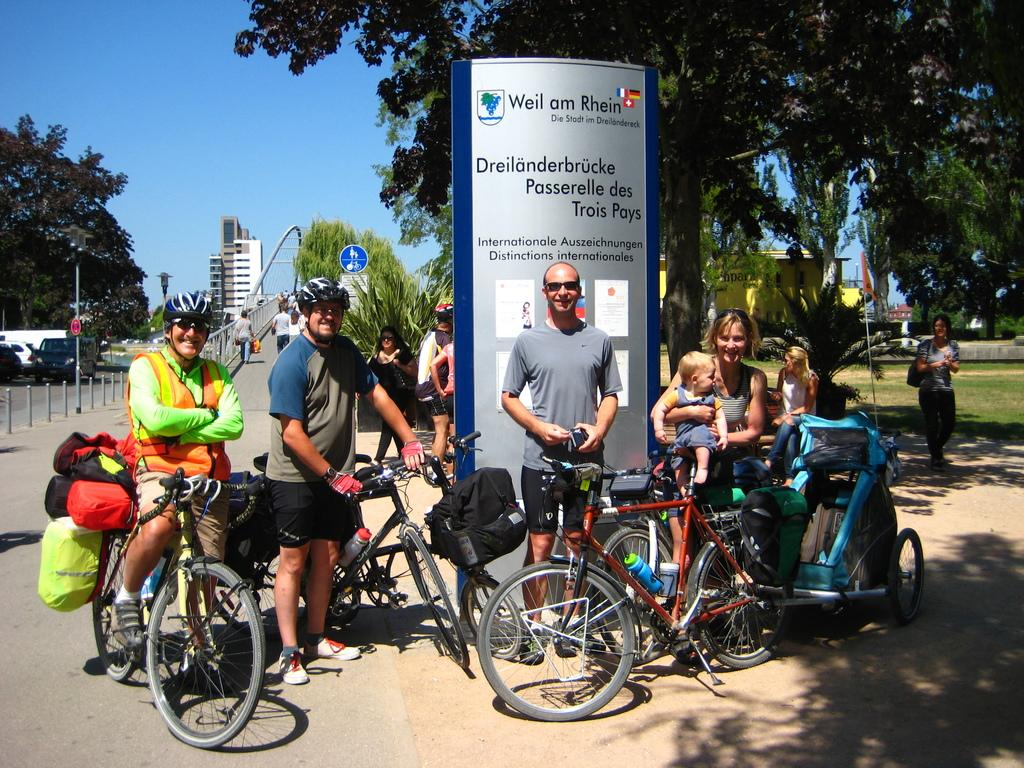What are the people in the image doing? The people in the image are on bicycles. What can be seen in the background of the image? There are trees, buildings, and a bridge visible in the background of the image. What is on the left side of the image? There is a car on the left side of the image. What is visible over the top of the image? The sky is visible over the top of the image. Can you touch the addition in the image? There is no addition present in the image; it is a scene featuring people on bicycles, a car, trees, buildings, a bridge, and the sky. What type of hall is visible in the image? There is no hall present in the image; it is a scene featuring people on bicycles, a car, trees, buildings, a bridge, and the sky. 